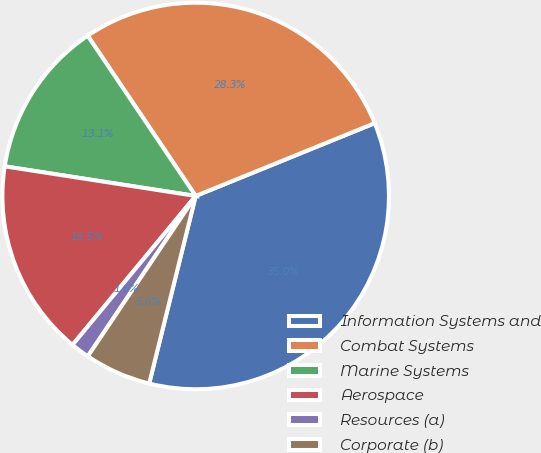Convert chart to OTSL. <chart><loc_0><loc_0><loc_500><loc_500><pie_chart><fcel>Information Systems and<fcel>Combat Systems<fcel>Marine Systems<fcel>Aerospace<fcel>Resources (a)<fcel>Corporate (b)<nl><fcel>35.01%<fcel>28.29%<fcel>13.11%<fcel>16.45%<fcel>1.57%<fcel>5.56%<nl></chart> 